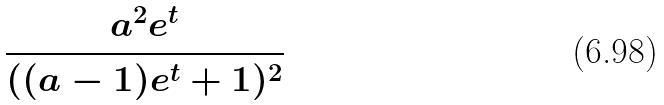Convert formula to latex. <formula><loc_0><loc_0><loc_500><loc_500>\frac { a ^ { 2 } e ^ { t } } { ( ( a - 1 ) e ^ { t } + 1 ) ^ { 2 } }</formula> 